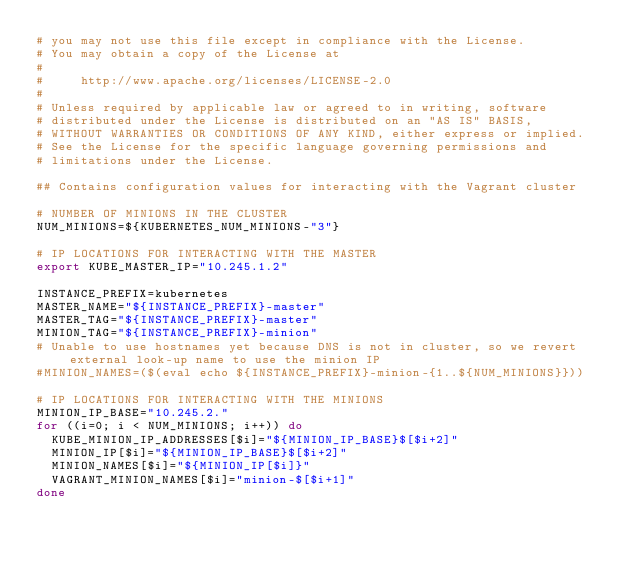<code> <loc_0><loc_0><loc_500><loc_500><_Bash_># you may not use this file except in compliance with the License.
# You may obtain a copy of the License at
#
#     http://www.apache.org/licenses/LICENSE-2.0
#
# Unless required by applicable law or agreed to in writing, software
# distributed under the License is distributed on an "AS IS" BASIS,
# WITHOUT WARRANTIES OR CONDITIONS OF ANY KIND, either express or implied.
# See the License for the specific language governing permissions and
# limitations under the License.

## Contains configuration values for interacting with the Vagrant cluster

# NUMBER OF MINIONS IN THE CLUSTER
NUM_MINIONS=${KUBERNETES_NUM_MINIONS-"3"}

# IP LOCATIONS FOR INTERACTING WITH THE MASTER
export KUBE_MASTER_IP="10.245.1.2"

INSTANCE_PREFIX=kubernetes
MASTER_NAME="${INSTANCE_PREFIX}-master"
MASTER_TAG="${INSTANCE_PREFIX}-master"
MINION_TAG="${INSTANCE_PREFIX}-minion"
# Unable to use hostnames yet because DNS is not in cluster, so we revert external look-up name to use the minion IP
#MINION_NAMES=($(eval echo ${INSTANCE_PREFIX}-minion-{1..${NUM_MINIONS}}))

# IP LOCATIONS FOR INTERACTING WITH THE MINIONS
MINION_IP_BASE="10.245.2."
for ((i=0; i < NUM_MINIONS; i++)) do
  KUBE_MINION_IP_ADDRESSES[$i]="${MINION_IP_BASE}$[$i+2]"
  MINION_IP[$i]="${MINION_IP_BASE}$[$i+2]"
  MINION_NAMES[$i]="${MINION_IP[$i]}"
  VAGRANT_MINION_NAMES[$i]="minion-$[$i+1]"
done
</code> 